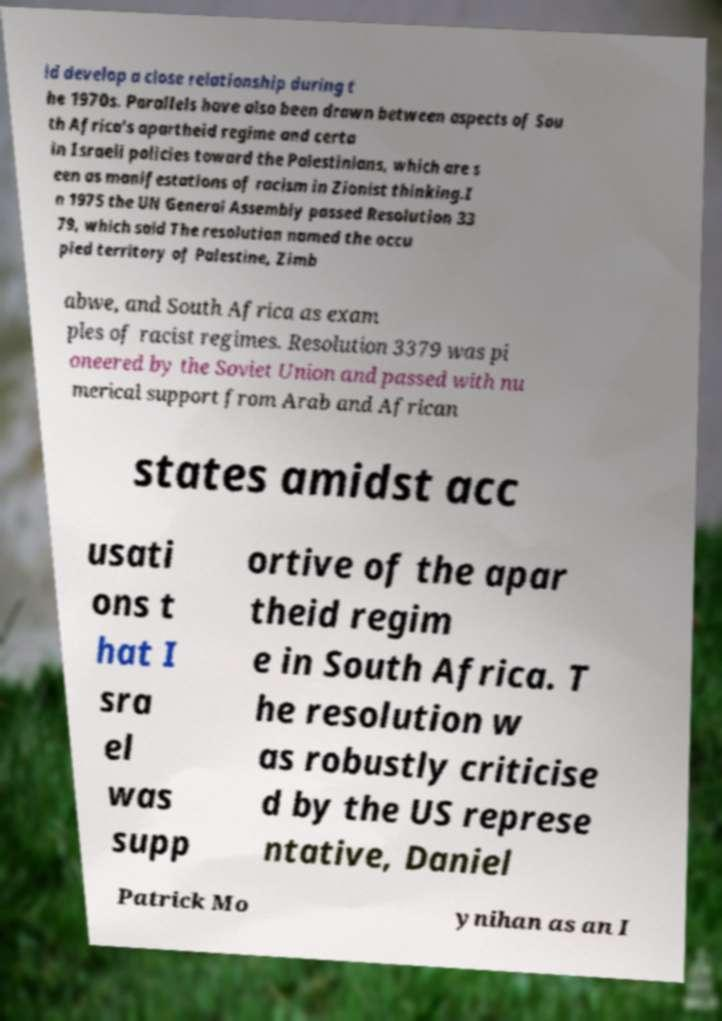There's text embedded in this image that I need extracted. Can you transcribe it verbatim? ld develop a close relationship during t he 1970s. Parallels have also been drawn between aspects of Sou th Africa's apartheid regime and certa in Israeli policies toward the Palestinians, which are s een as manifestations of racism in Zionist thinking.I n 1975 the UN General Assembly passed Resolution 33 79, which said The resolution named the occu pied territory of Palestine, Zimb abwe, and South Africa as exam ples of racist regimes. Resolution 3379 was pi oneered by the Soviet Union and passed with nu merical support from Arab and African states amidst acc usati ons t hat I sra el was supp ortive of the apar theid regim e in South Africa. T he resolution w as robustly criticise d by the US represe ntative, Daniel Patrick Mo ynihan as an I 